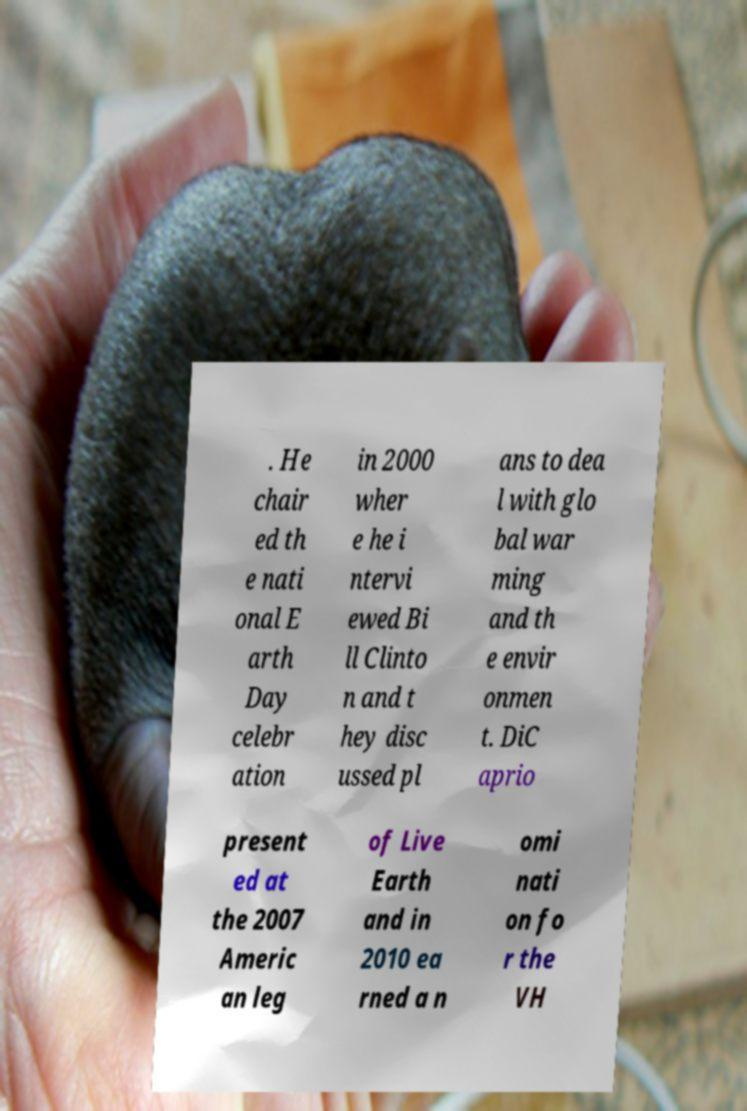Please identify and transcribe the text found in this image. . He chair ed th e nati onal E arth Day celebr ation in 2000 wher e he i ntervi ewed Bi ll Clinto n and t hey disc ussed pl ans to dea l with glo bal war ming and th e envir onmen t. DiC aprio present ed at the 2007 Americ an leg of Live Earth and in 2010 ea rned a n omi nati on fo r the VH 